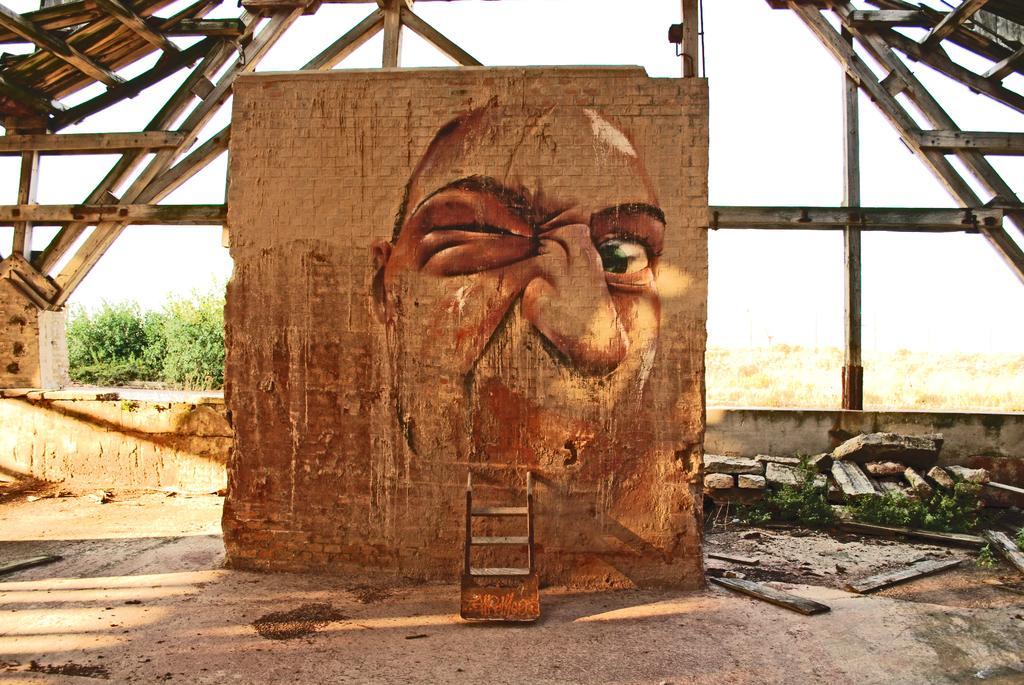How would you summarize this image in a sentence or two? In this picture can see a brick wall on it there is a painting, behind we can see some poles. 